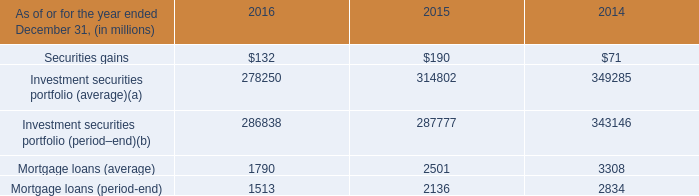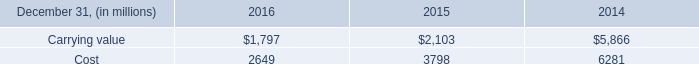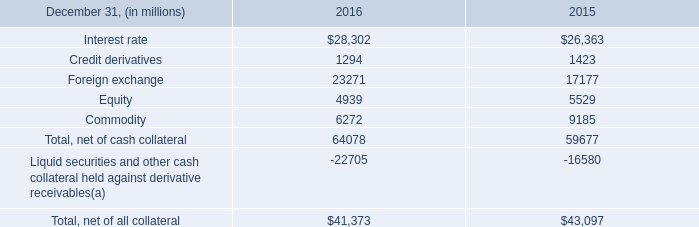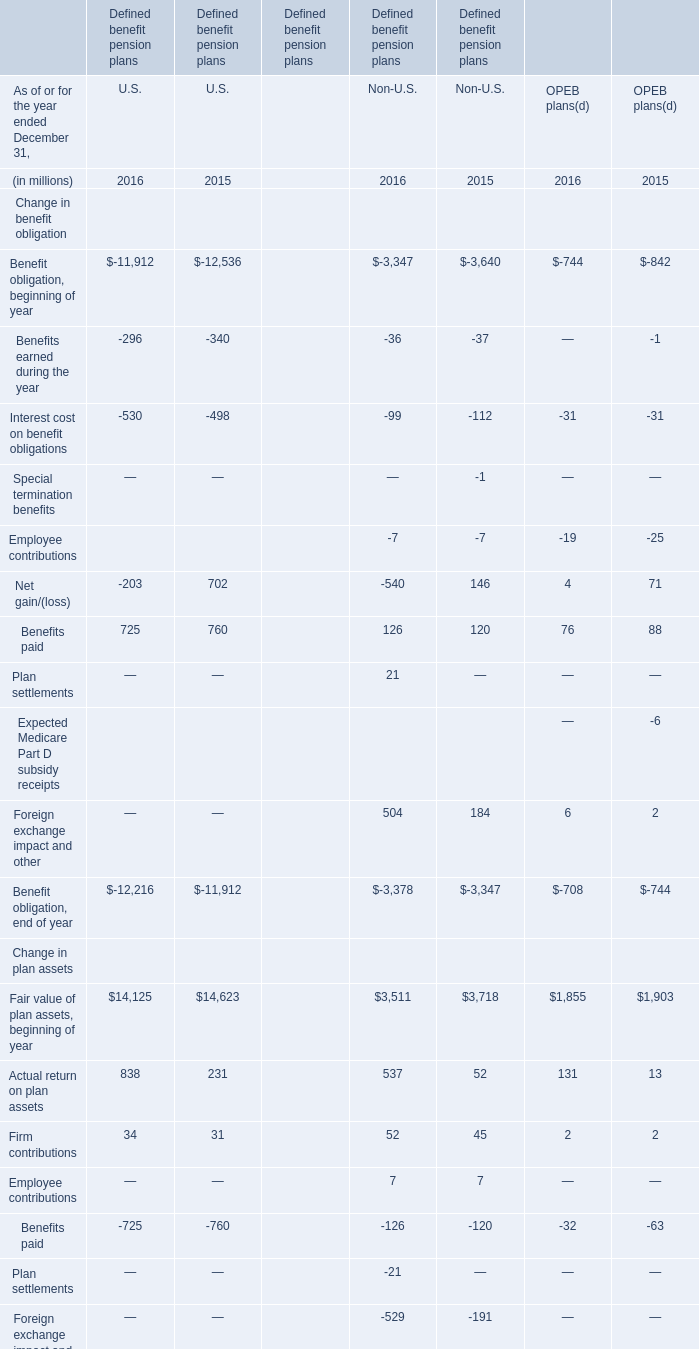what was the net three year avg derivative liability exposure , in billions , for 2016? 
Computations: (31.1 - 41.4)
Answer: -10.3. 